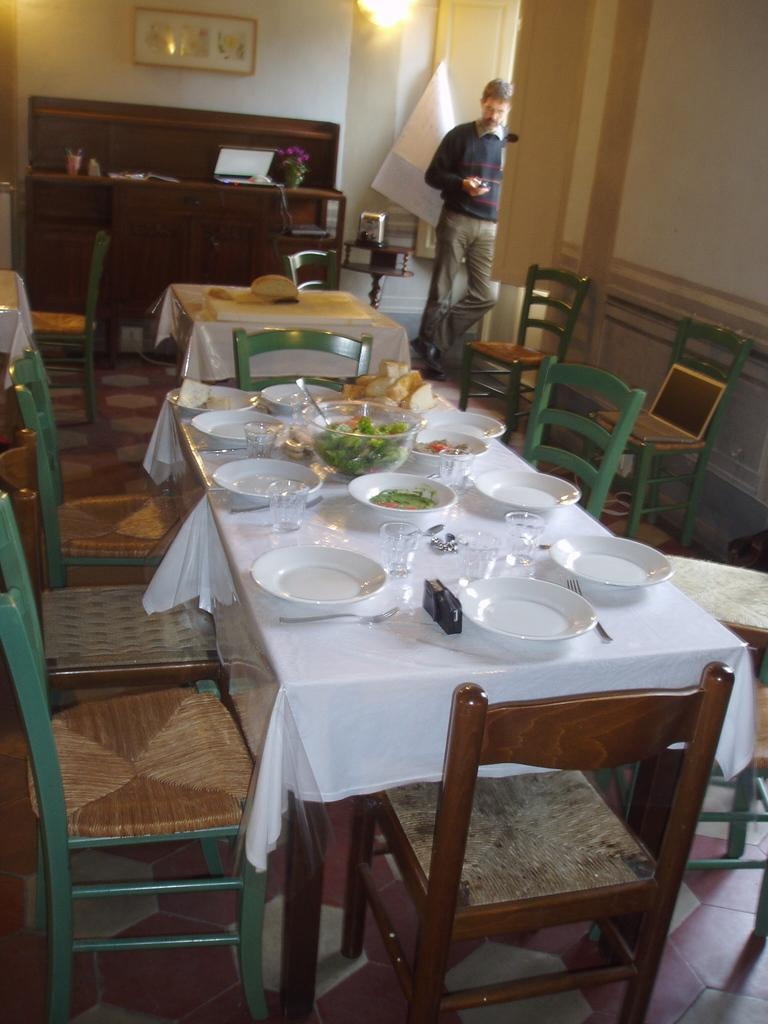What type of furniture is in the image? There is a dining table in the image. What accompanies the dining table? Chairs are present around the dining table. What can be seen in the background of the image? There is a person standing, a wall, a laptop, a light, and a photo frame in the background of the image. What type of pollution is visible in the image? There is no visible pollution in the image. How many fingers does the person in the background have? The number of fingers the person in the background has cannot be determined from the image. 